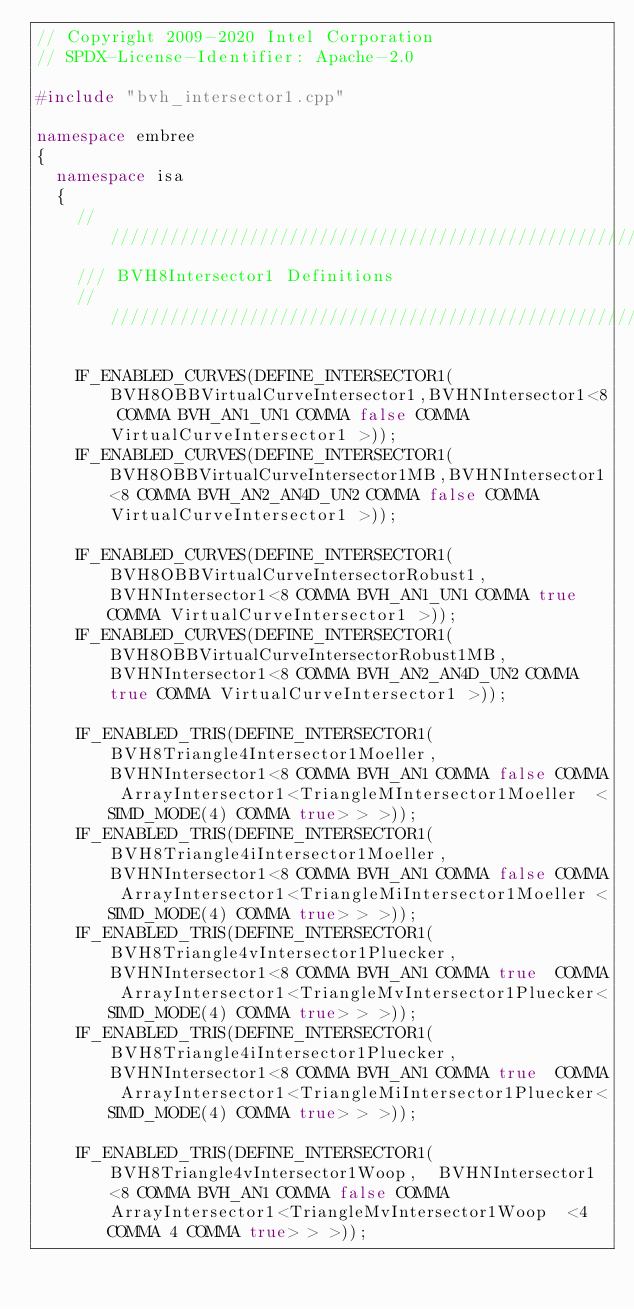<code> <loc_0><loc_0><loc_500><loc_500><_C++_>// Copyright 2009-2020 Intel Corporation
// SPDX-License-Identifier: Apache-2.0

#include "bvh_intersector1.cpp"

namespace embree
{
  namespace isa
  {
    ////////////////////////////////////////////////////////////////////////////////
    /// BVH8Intersector1 Definitions
    ////////////////////////////////////////////////////////////////////////////////

    IF_ENABLED_CURVES(DEFINE_INTERSECTOR1(BVH8OBBVirtualCurveIntersector1,BVHNIntersector1<8 COMMA BVH_AN1_UN1 COMMA false COMMA VirtualCurveIntersector1 >));
    IF_ENABLED_CURVES(DEFINE_INTERSECTOR1(BVH8OBBVirtualCurveIntersector1MB,BVHNIntersector1<8 COMMA BVH_AN2_AN4D_UN2 COMMA false COMMA VirtualCurveIntersector1 >));

    IF_ENABLED_CURVES(DEFINE_INTERSECTOR1(BVH8OBBVirtualCurveIntersectorRobust1,BVHNIntersector1<8 COMMA BVH_AN1_UN1 COMMA true COMMA VirtualCurveIntersector1 >));
    IF_ENABLED_CURVES(DEFINE_INTERSECTOR1(BVH8OBBVirtualCurveIntersectorRobust1MB,BVHNIntersector1<8 COMMA BVH_AN2_AN4D_UN2 COMMA true COMMA VirtualCurveIntersector1 >));

    IF_ENABLED_TRIS(DEFINE_INTERSECTOR1(BVH8Triangle4Intersector1Moeller,  BVHNIntersector1<8 COMMA BVH_AN1 COMMA false COMMA ArrayIntersector1<TriangleMIntersector1Moeller  <SIMD_MODE(4) COMMA true> > >));
    IF_ENABLED_TRIS(DEFINE_INTERSECTOR1(BVH8Triangle4iIntersector1Moeller, BVHNIntersector1<8 COMMA BVH_AN1 COMMA false COMMA ArrayIntersector1<TriangleMiIntersector1Moeller <SIMD_MODE(4) COMMA true> > >));
    IF_ENABLED_TRIS(DEFINE_INTERSECTOR1(BVH8Triangle4vIntersector1Pluecker,BVHNIntersector1<8 COMMA BVH_AN1 COMMA true  COMMA ArrayIntersector1<TriangleMvIntersector1Pluecker<SIMD_MODE(4) COMMA true> > >));
    IF_ENABLED_TRIS(DEFINE_INTERSECTOR1(BVH8Triangle4iIntersector1Pluecker,BVHNIntersector1<8 COMMA BVH_AN1 COMMA true  COMMA ArrayIntersector1<TriangleMiIntersector1Pluecker<SIMD_MODE(4) COMMA true> > >));

    IF_ENABLED_TRIS(DEFINE_INTERSECTOR1(BVH8Triangle4vIntersector1Woop,  BVHNIntersector1<8 COMMA BVH_AN1 COMMA false COMMA ArrayIntersector1<TriangleMvIntersector1Woop  <4 COMMA 4 COMMA true> > >));
</code> 